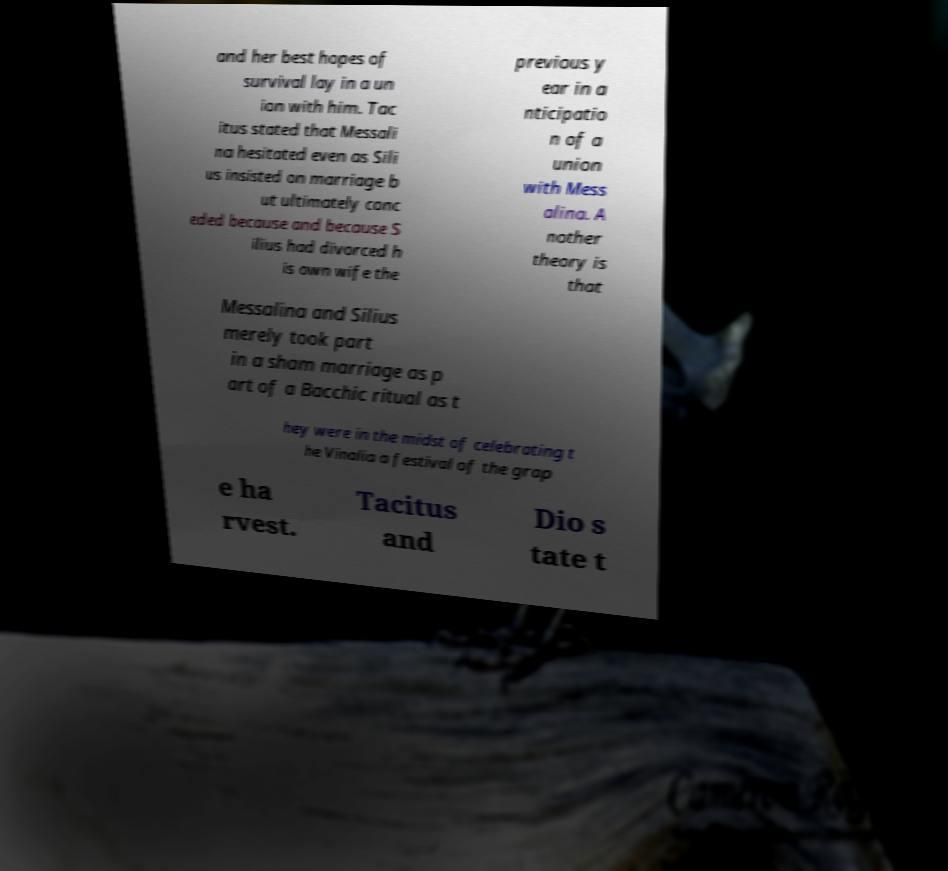Can you accurately transcribe the text from the provided image for me? and her best hopes of survival lay in a un ion with him. Tac itus stated that Messali na hesitated even as Sili us insisted on marriage b ut ultimately conc eded because and because S ilius had divorced h is own wife the previous y ear in a nticipatio n of a union with Mess alina. A nother theory is that Messalina and Silius merely took part in a sham marriage as p art of a Bacchic ritual as t hey were in the midst of celebrating t he Vinalia a festival of the grap e ha rvest. Tacitus and Dio s tate t 